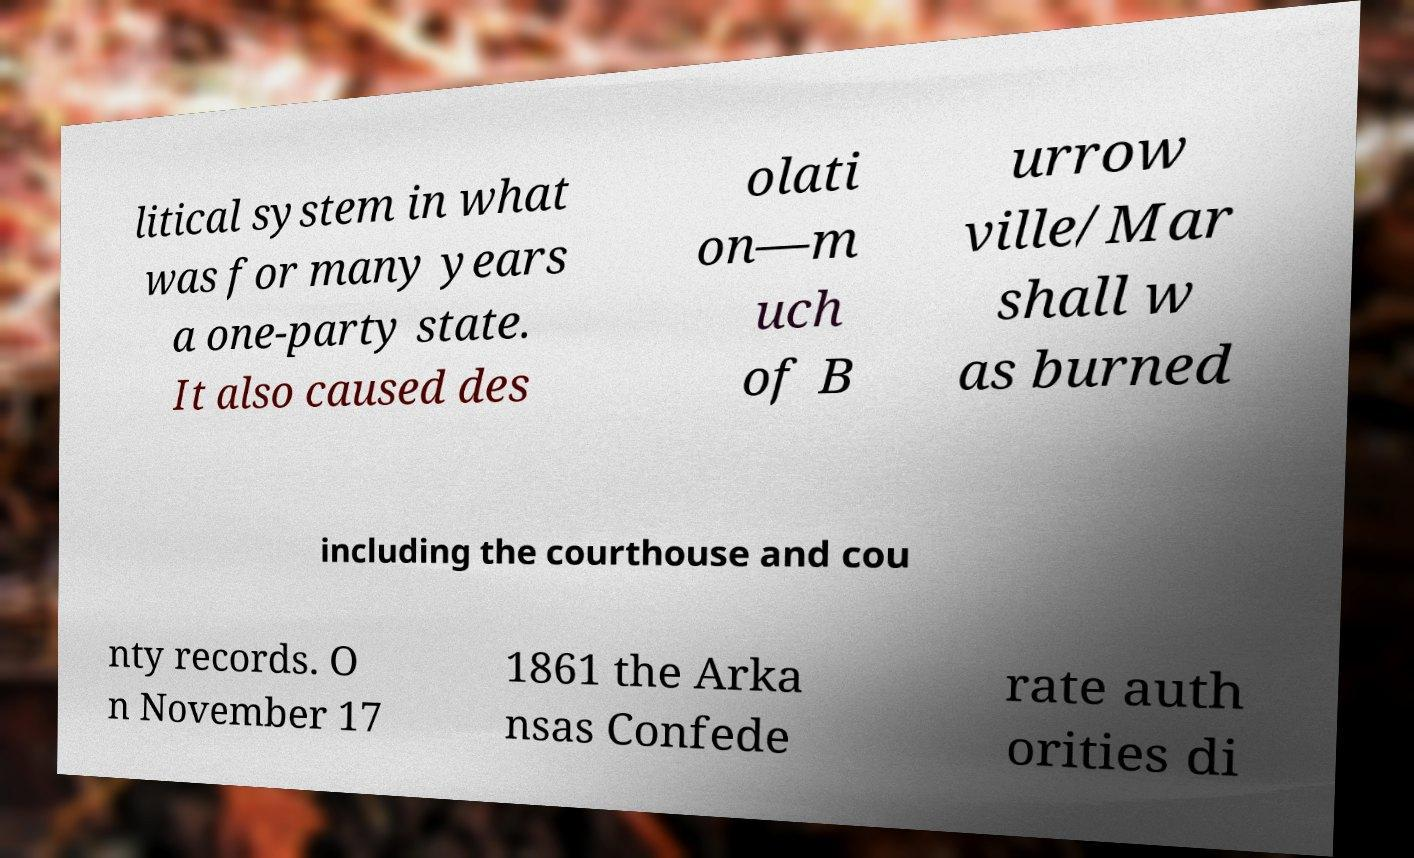There's text embedded in this image that I need extracted. Can you transcribe it verbatim? litical system in what was for many years a one-party state. It also caused des olati on—m uch of B urrow ville/Mar shall w as burned including the courthouse and cou nty records. O n November 17 1861 the Arka nsas Confede rate auth orities di 